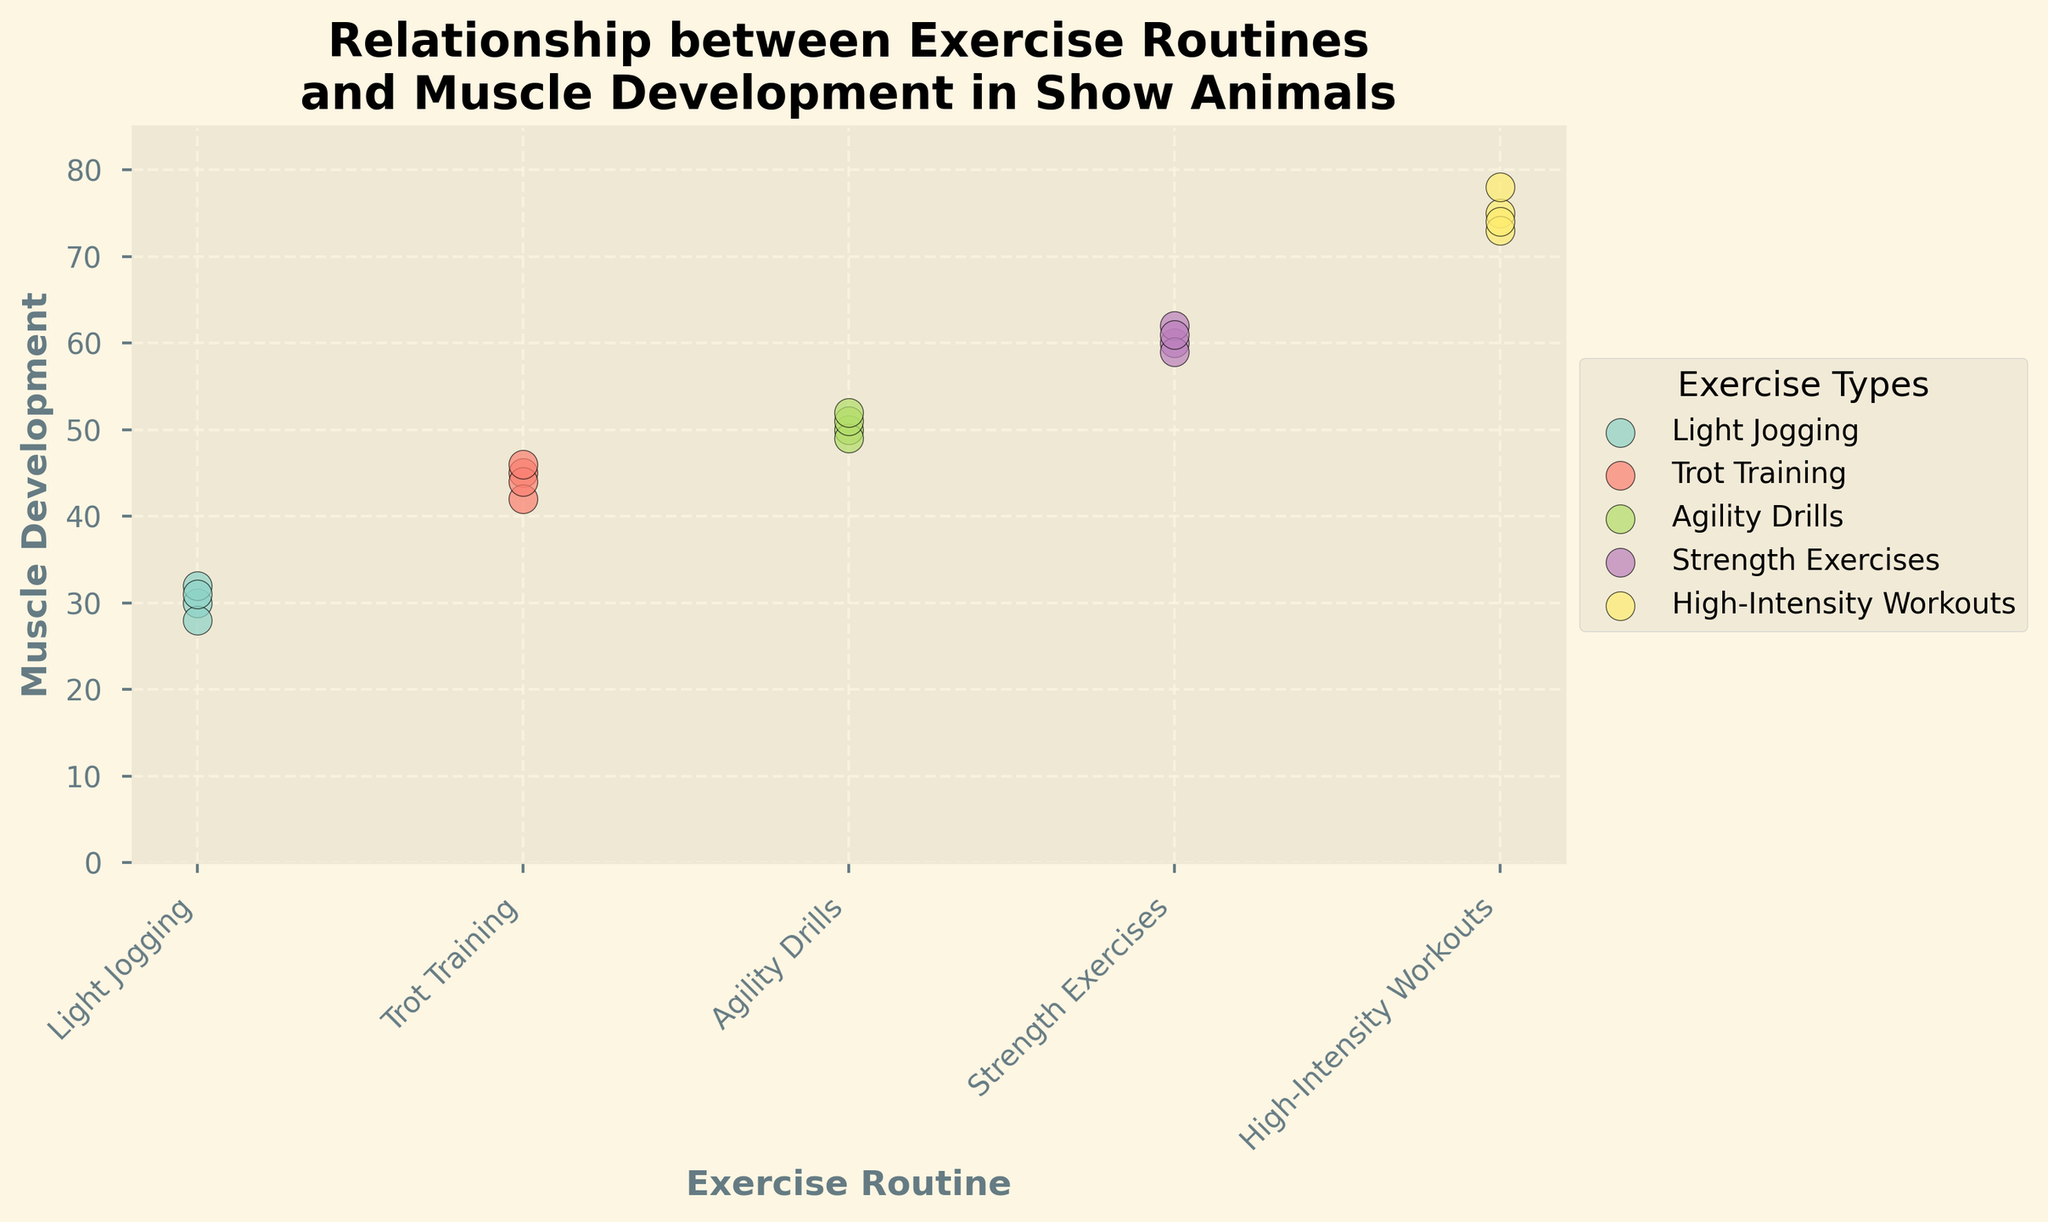What is the title of the figure? The title is generally displayed at the top of the figure. Here it should describe the relationship being observed between exercise routines and muscle development in show animals.
Answer: Relationship between Exercise Routines and Muscle Development in Show Animals What are the labels of the x-axis and y-axis? Axis labels are located on the horizontal (x) and vertical (y) lines. The x-axis displays the category, and the y-axis shows the measurement.
Answer: X-axis: Exercise Routine, Y-axis: Muscle Development Which exercise routine group has the lowest muscle development values? Identify the group with the smallest y-values by observing the scatter points positioned lower on the chart.
Answer: Light Jogging How many different exercise routines are compared in the figure? Each unique color corresponds to a different exercise routine; count the distinct colors.
Answer: 5 What is the average muscle development observed in the "High-Intensity Workouts" group? Extract the y-values for all data points labeled as "High-Intensity Workouts," sum them up, and divide by the number of points (75 + 73 + 78 + 74) / 4 = 75.
Answer: 75 Which two exercise routines have overlapping muscle development ranges? Compare the vertical spread of points to see which groups have similar y-value ranges.
Answer: Agility Drills and Trot Training What is the range of muscle development values for the "Strength Exercises" group? Identify the minimum and maximum y-values for "Strength Exercises"; subtract the minimum from the maximum (62 - 59) = 3.
Answer: 59 to 62 Is there a clear trend in muscle development as the intensity of exercise routine increases? Observe the general upward or downward pattern of y-values as exercise intensity changes from Light Jogging to High-Intensity Workouts.
Answer: Yes, muscle development increases with exercise intensity Which exercise routine has the most consistent muscle development values? Look for the group with the smallest range or spread in y-values.
Answer: Strength Exercises What's the median muscle development value for the "Agility Drills" group? Arrange the y-values in ascending order (49, 50, 51, 52) and find the middle value(s); the median is the average of the two middle values (50 + 51) / 2 = 50.5.
Answer: 50.5 